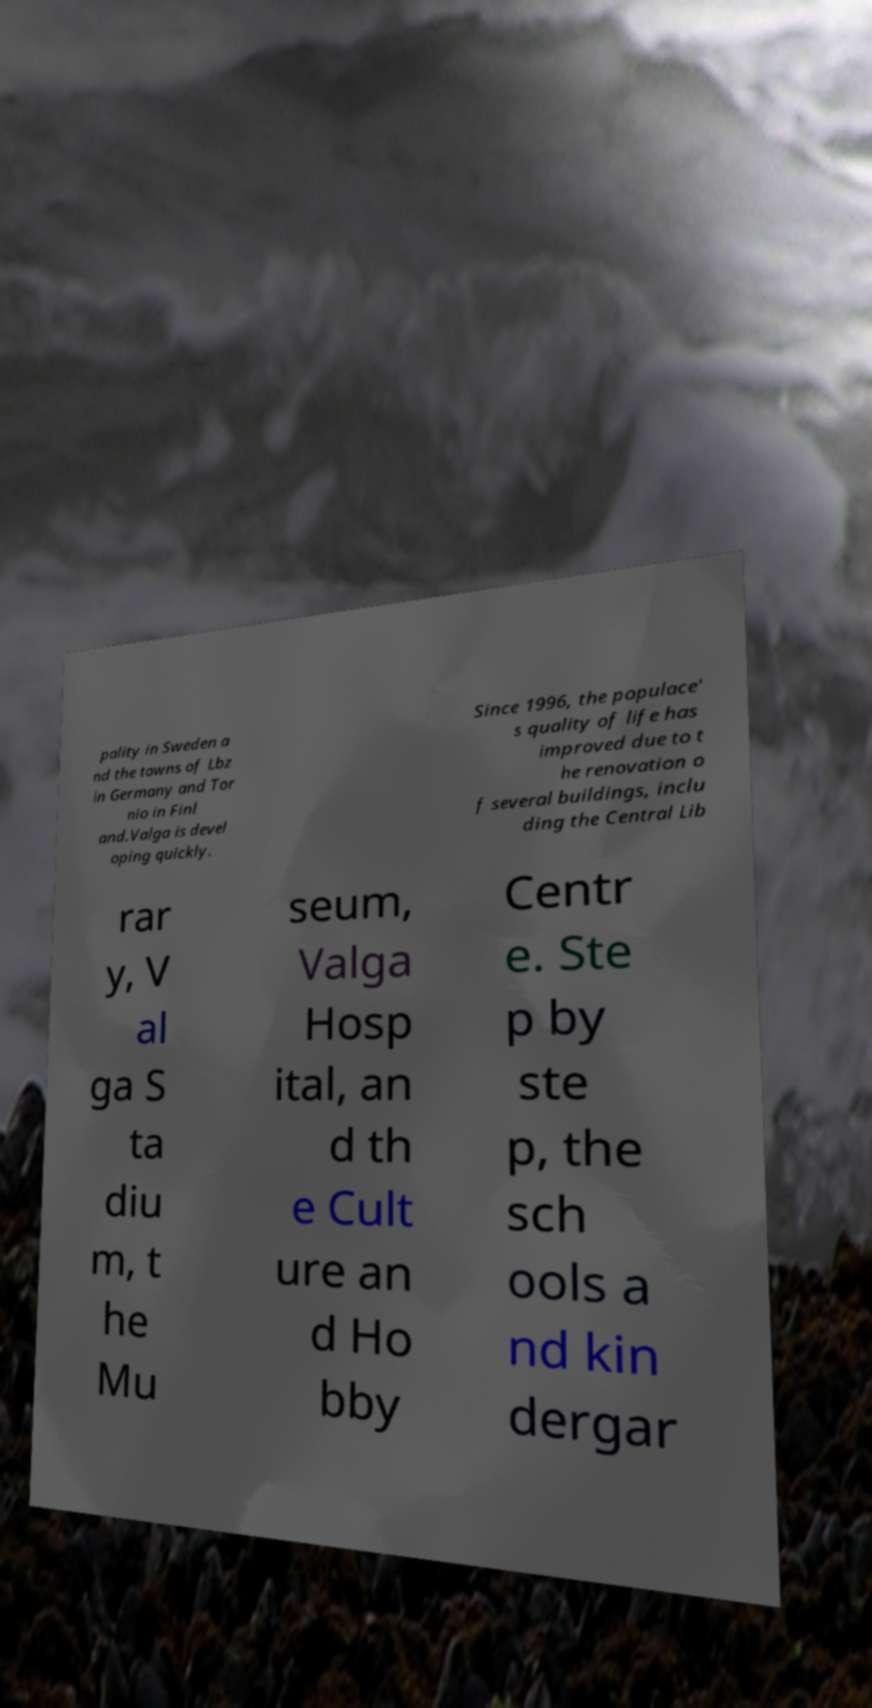Can you read and provide the text displayed in the image?This photo seems to have some interesting text. Can you extract and type it out for me? pality in Sweden a nd the towns of Lbz in Germany and Tor nio in Finl and.Valga is devel oping quickly. Since 1996, the populace' s quality of life has improved due to t he renovation o f several buildings, inclu ding the Central Lib rar y, V al ga S ta diu m, t he Mu seum, Valga Hosp ital, an d th e Cult ure an d Ho bby Centr e. Ste p by ste p, the sch ools a nd kin dergar 